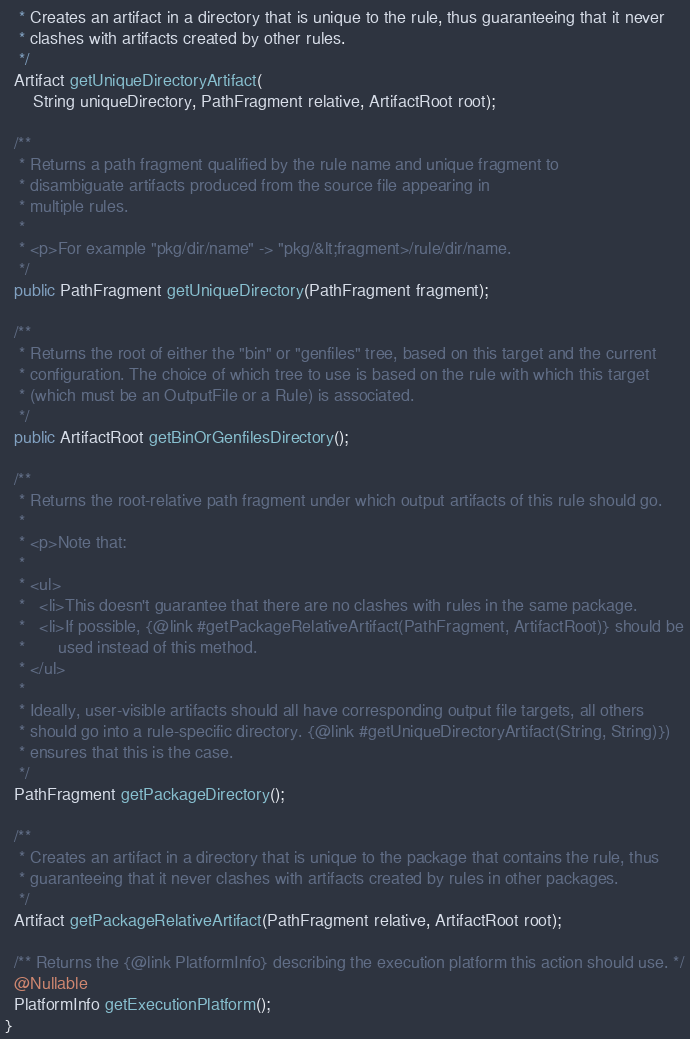Convert code to text. <code><loc_0><loc_0><loc_500><loc_500><_Java_>   * Creates an artifact in a directory that is unique to the rule, thus guaranteeing that it never
   * clashes with artifacts created by other rules.
   */
  Artifact getUniqueDirectoryArtifact(
      String uniqueDirectory, PathFragment relative, ArtifactRoot root);

  /**
   * Returns a path fragment qualified by the rule name and unique fragment to
   * disambiguate artifacts produced from the source file appearing in
   * multiple rules.
   *
   * <p>For example "pkg/dir/name" -> "pkg/&lt;fragment>/rule/dir/name.
   */
  public PathFragment getUniqueDirectory(PathFragment fragment);

  /**
   * Returns the root of either the "bin" or "genfiles" tree, based on this target and the current
   * configuration. The choice of which tree to use is based on the rule with which this target
   * (which must be an OutputFile or a Rule) is associated.
   */
  public ArtifactRoot getBinOrGenfilesDirectory();

  /**
   * Returns the root-relative path fragment under which output artifacts of this rule should go.
   *
   * <p>Note that:
   *
   * <ul>
   *   <li>This doesn't guarantee that there are no clashes with rules in the same package.
   *   <li>If possible, {@link #getPackageRelativeArtifact(PathFragment, ArtifactRoot)} should be
   *       used instead of this method.
   * </ul>
   *
   * Ideally, user-visible artifacts should all have corresponding output file targets, all others
   * should go into a rule-specific directory. {@link #getUniqueDirectoryArtifact(String, String)})
   * ensures that this is the case.
   */
  PathFragment getPackageDirectory();

  /**
   * Creates an artifact in a directory that is unique to the package that contains the rule, thus
   * guaranteeing that it never clashes with artifacts created by rules in other packages.
   */
  Artifact getPackageRelativeArtifact(PathFragment relative, ArtifactRoot root);

  /** Returns the {@link PlatformInfo} describing the execution platform this action should use. */
  @Nullable
  PlatformInfo getExecutionPlatform();
}
</code> 